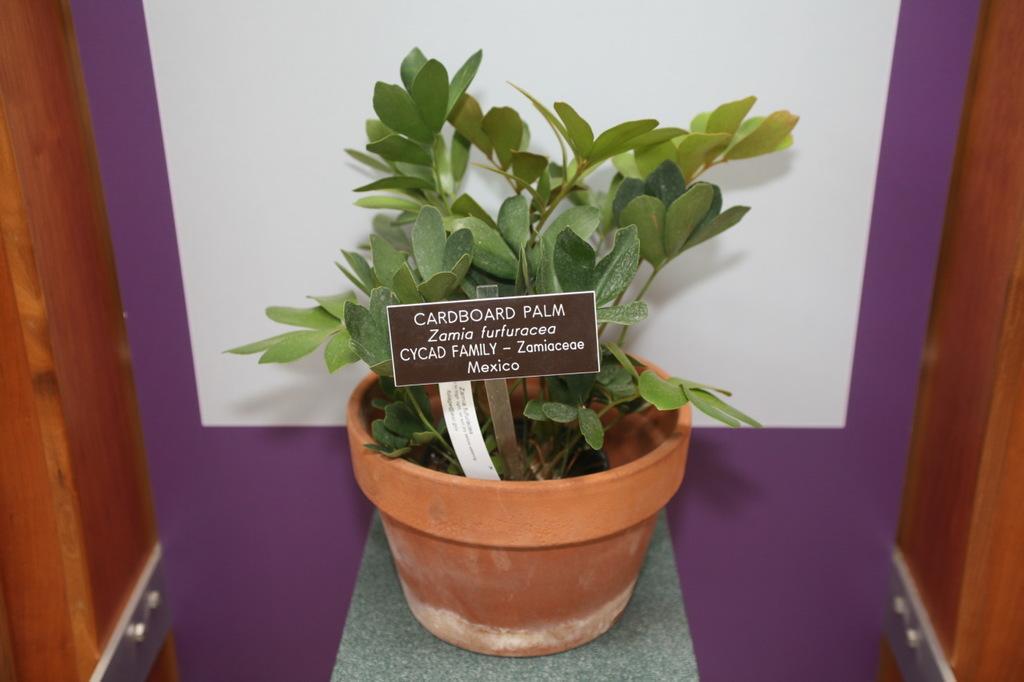Please provide a concise description of this image. In this image, there is a plant contains some small board. 